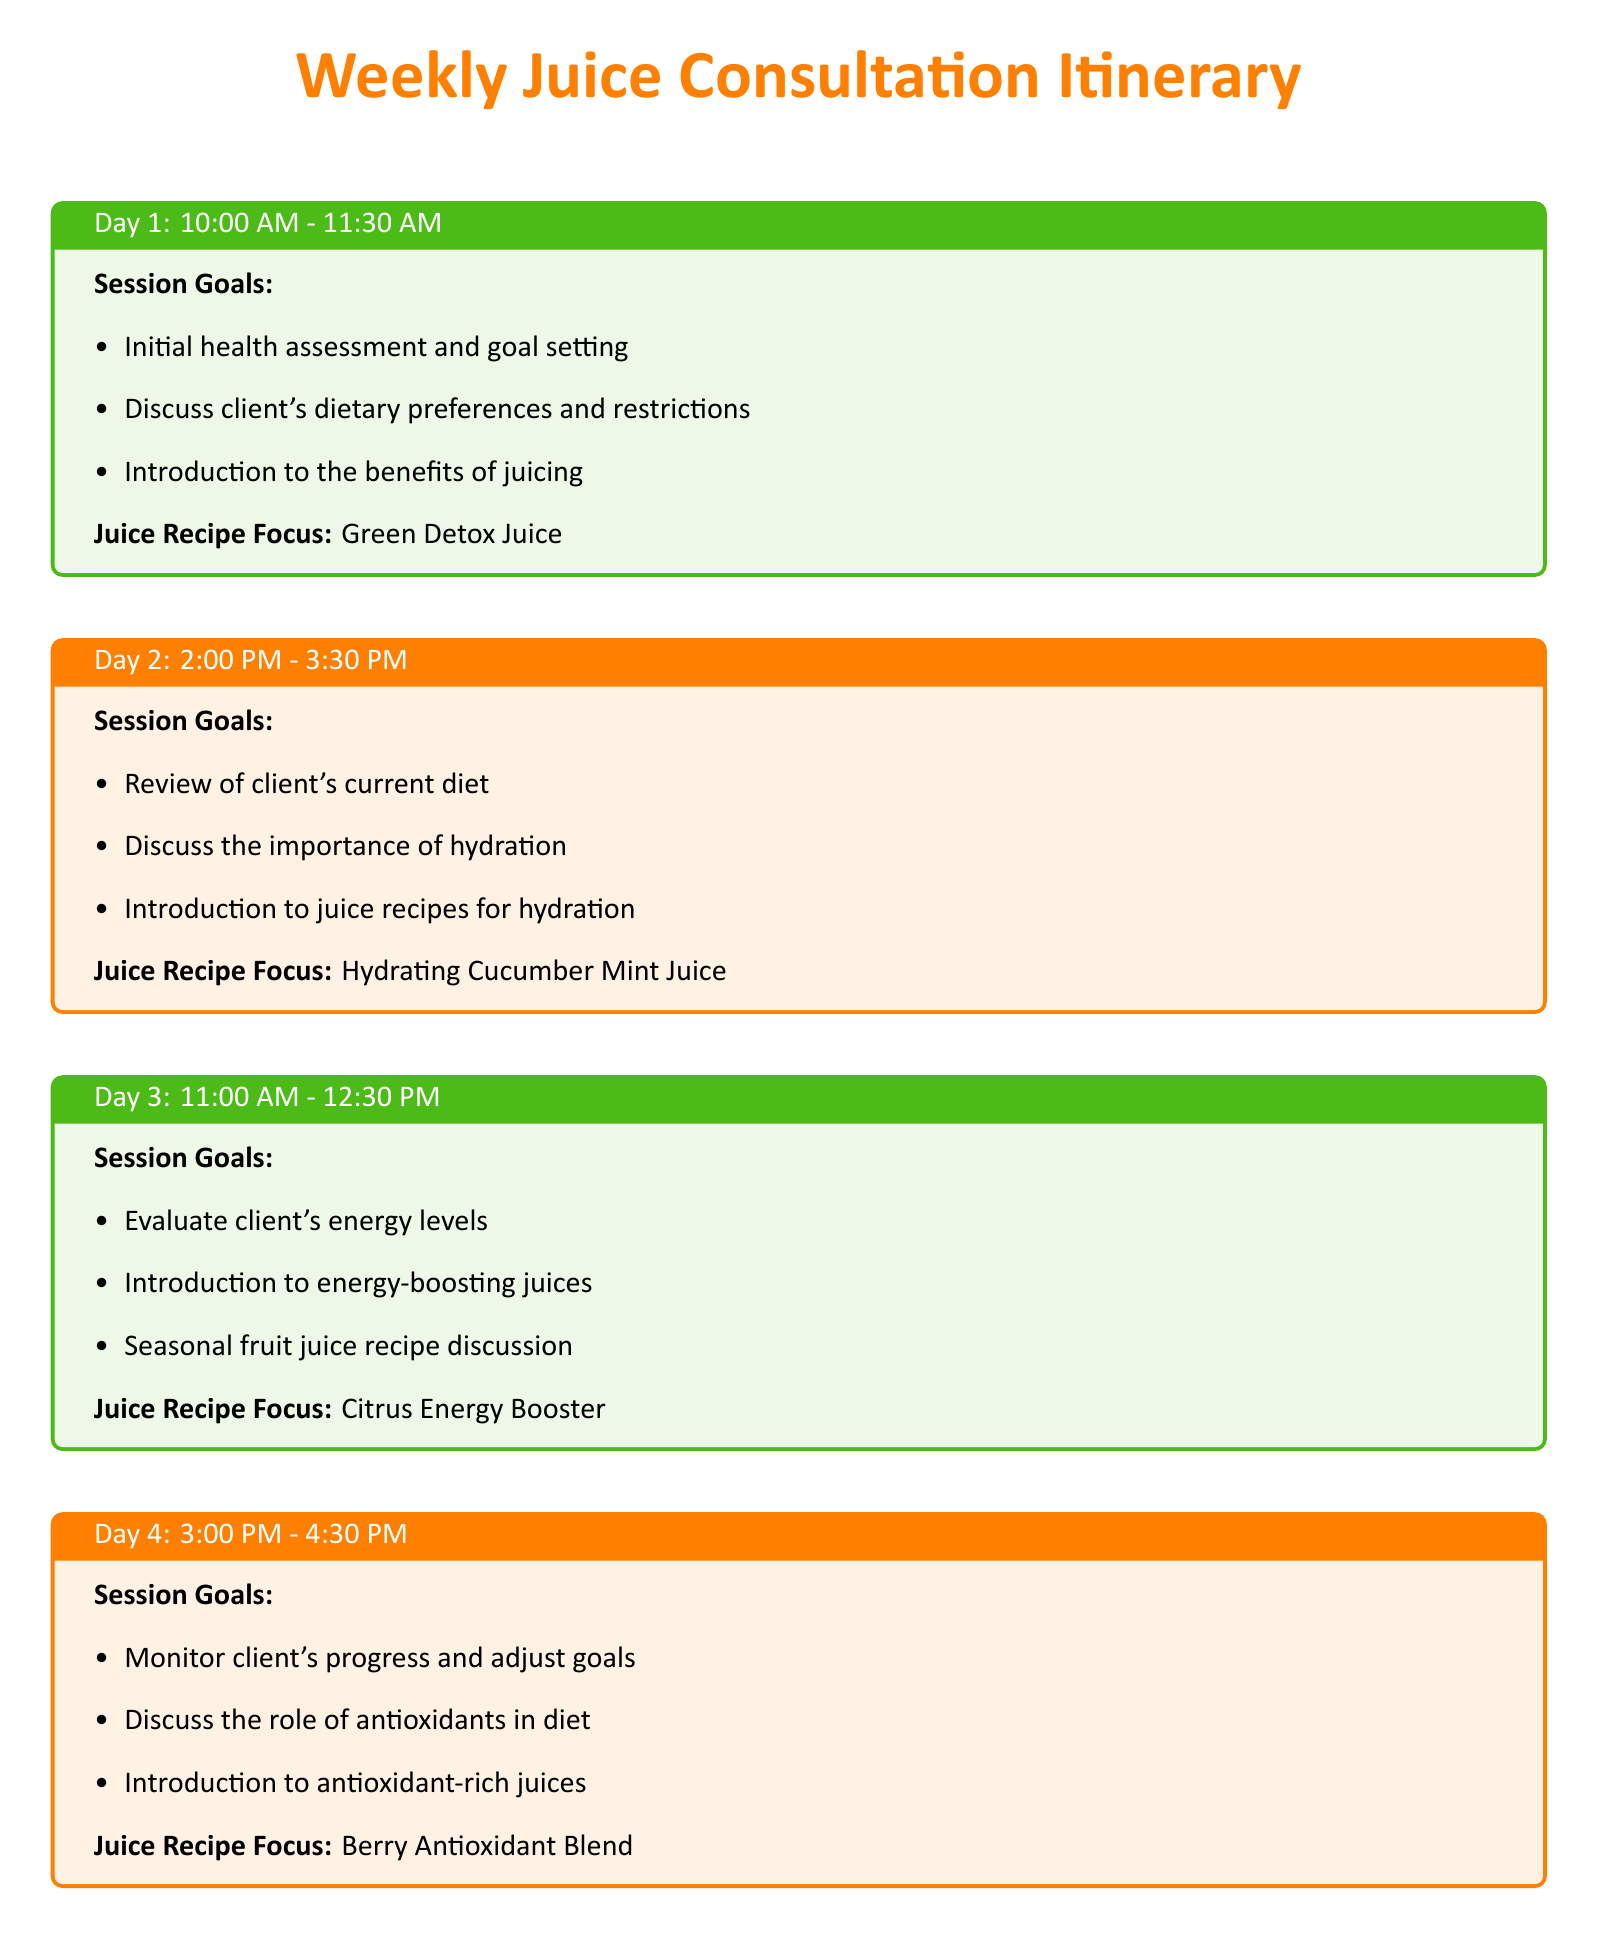What is the focus of the juice recipe on Day 1? The juice recipe focus for Day 1 is mentioned in the itinerary, which states it as "Green Detox Juice."
Answer: Green Detox Juice What time is the consultation on Day 3 scheduled? The consultation on Day 3 is scheduled from 11:00 AM to 12:30 PM according to the timetable provided in the document.
Answer: 11:00 AM - 12:30 PM How many session goals are listed for Day 4? The document outlines three specific session goals for Day 4, which can be counted directly in the corresponding section.
Answer: 3 What is the main theme for the juice recipes throughout the week? The main theme revolves around different health benefits as indicated in the session goals, requiring reasoning over the entire schedule's content.
Answer: Health benefits What is the juice recipe focus for Day 2? The focus for Day 2 is specified under the corresponding session, which reads "Hydrating Cucumber Mint Juice."
Answer: Hydrating Cucumber Mint Juice What is the last session of the week? The last session of the week is detailed as occurring on Day 5 at 9:00 AM - 10:30 AM, confirming it as the final consultation.
Answer: Day 5 Which day includes a discussion on antioxidants? The day that includes a discussion on antioxidants is explicitly stated in the Day 4 session overview.
Answer: Day 4 What type of juice does the Day 5 session focus on? The focus for Day 5 is stated as "Tropical Morning Juice" in the detailed session goals.
Answer: Tropical Morning Juice 